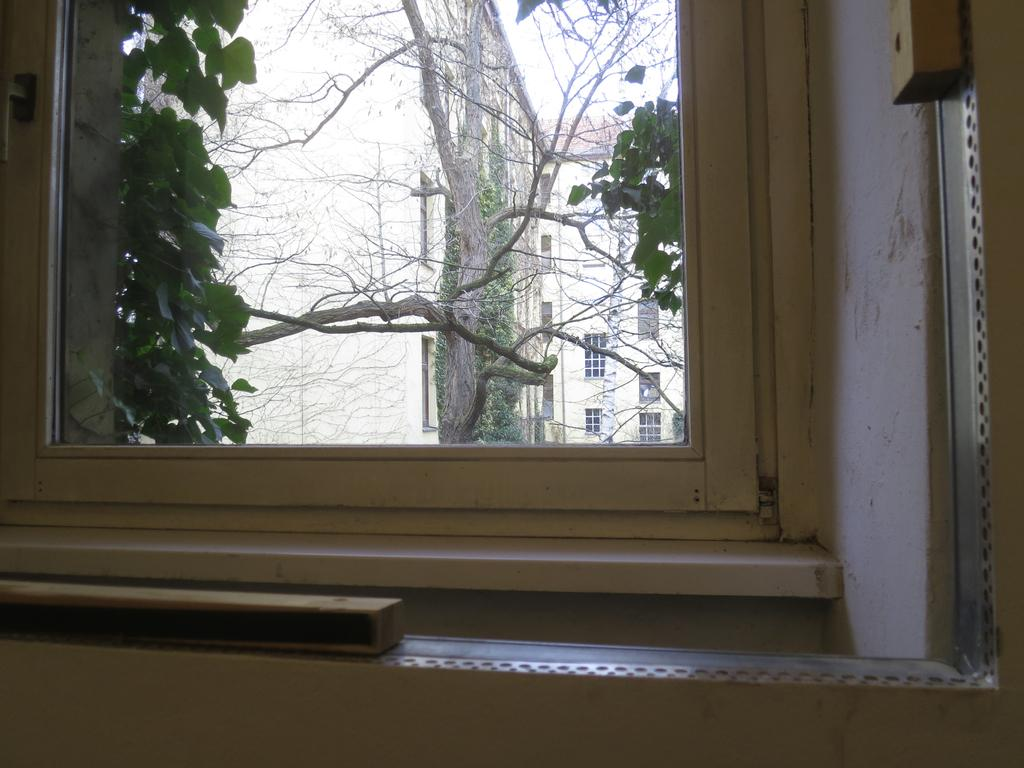What is one of the main features of the image? There is a window in the image. What else can be seen through the window? Objects and trees are visible in the image. What is visible in the background of the image? There are buildings with windows and the sky in the background of the image. How many men are standing on the legs of the peace symbol in the image? There is no peace symbol or men present in the image. 